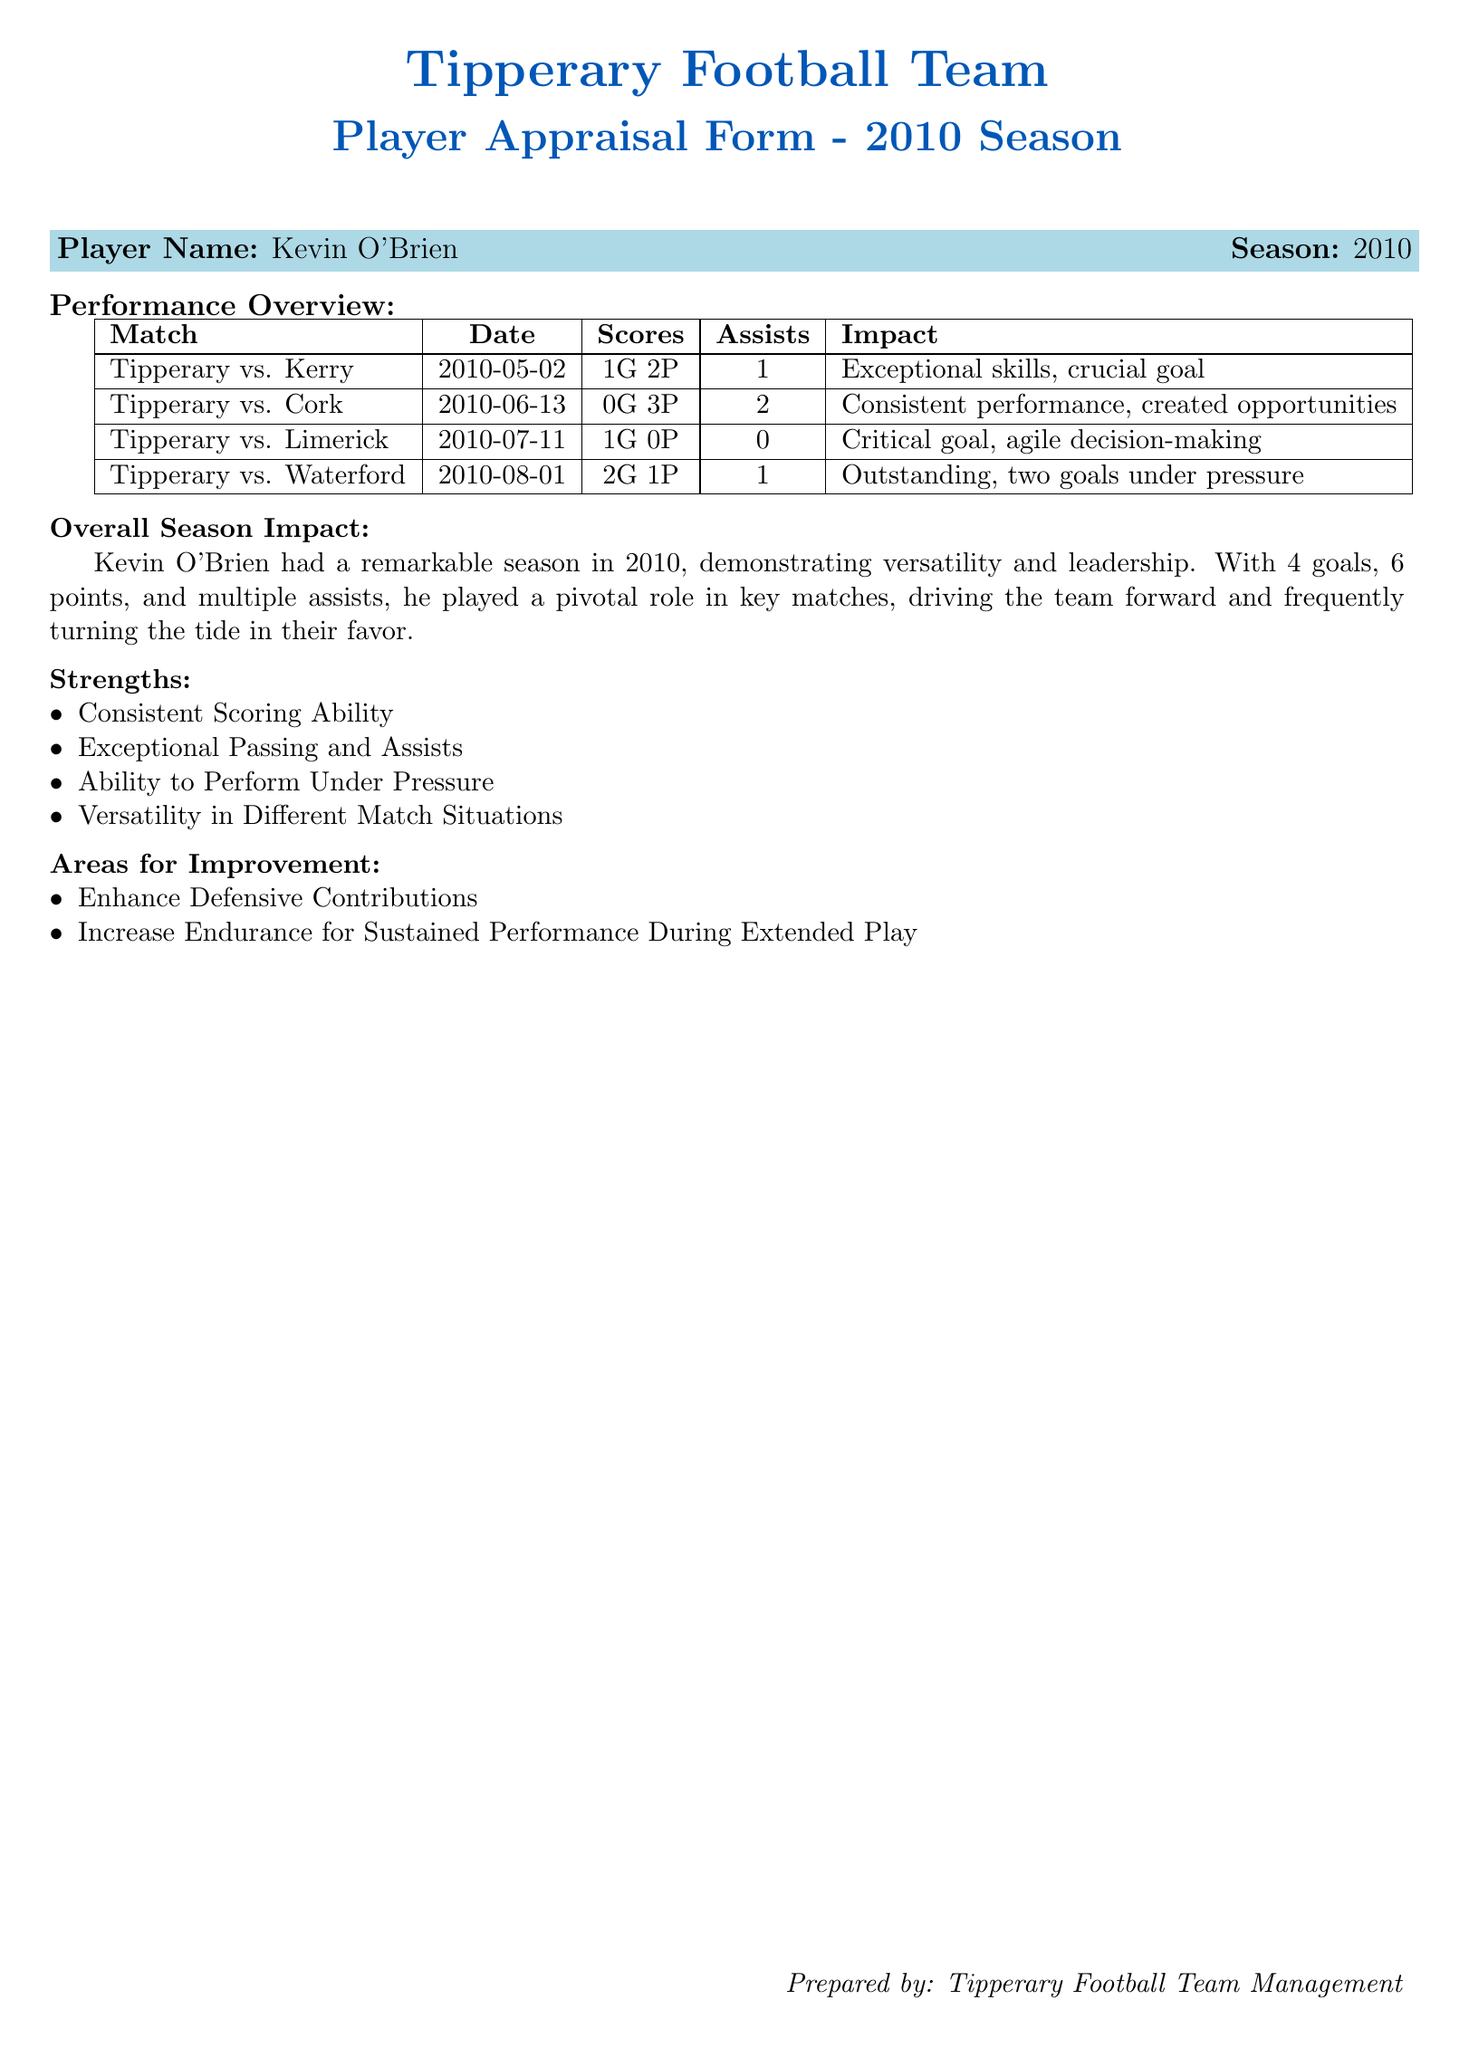What was Kevin O'Brien's total score in the 2010 season? The total score consists of goals and points scored, which is 4 goals and 6 points, totaling 4G 6P.
Answer: 4G 6P How many assists did Kevin O'Brien provide during the season? The document lists the number of assists across the matches, which totals to 4 assists.
Answer: 4 Which match had the date of May 2, 2010? The match on this date is Tipperary vs. Kerry, which is recorded as the first match in the table.
Answer: Tipperary vs. Kerry What was Kevin O'Brien's impact in the match against Waterford? The impact noted for the match against Waterford highlights his outstanding performance with two goals achieved under pressure.
Answer: Outstanding, two goals under pressure What area for improvement was mentioned regarding Kevin O'Brien's performance? The appraisal form states that he should enhance his defensive contributions for improvement.
Answer: Enhance Defensive Contributions How many points did Kevin O'Brien score against Cork? The score against Cork includes 0 goals and 3 points, so he scored 3 points during that match.
Answer: 3P What strengths did Kevin O'Brien demonstrate throughout the season? The document lists several strengths, including consistent scoring ability and exceptional passing.
Answer: Consistent Scoring Ability What was Kevin O'Brien's performance in the Limerick match? During that match, he scored 1 goal and made no assists, which indicates a critical contribution.
Answer: Critical goal Which match had the highest number of goals scored by Kevin O'Brien? The match against Waterford had him scoring the highest with 2 goals.
Answer: Waterford 